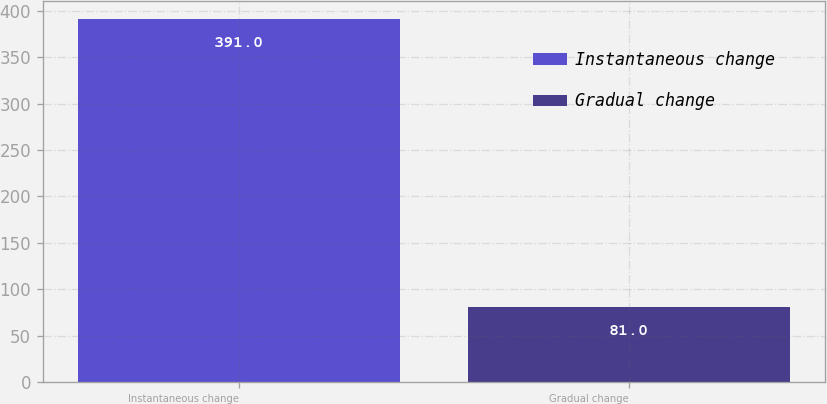Convert chart to OTSL. <chart><loc_0><loc_0><loc_500><loc_500><bar_chart><fcel>Instantaneous change<fcel>Gradual change<nl><fcel>391<fcel>81<nl></chart> 